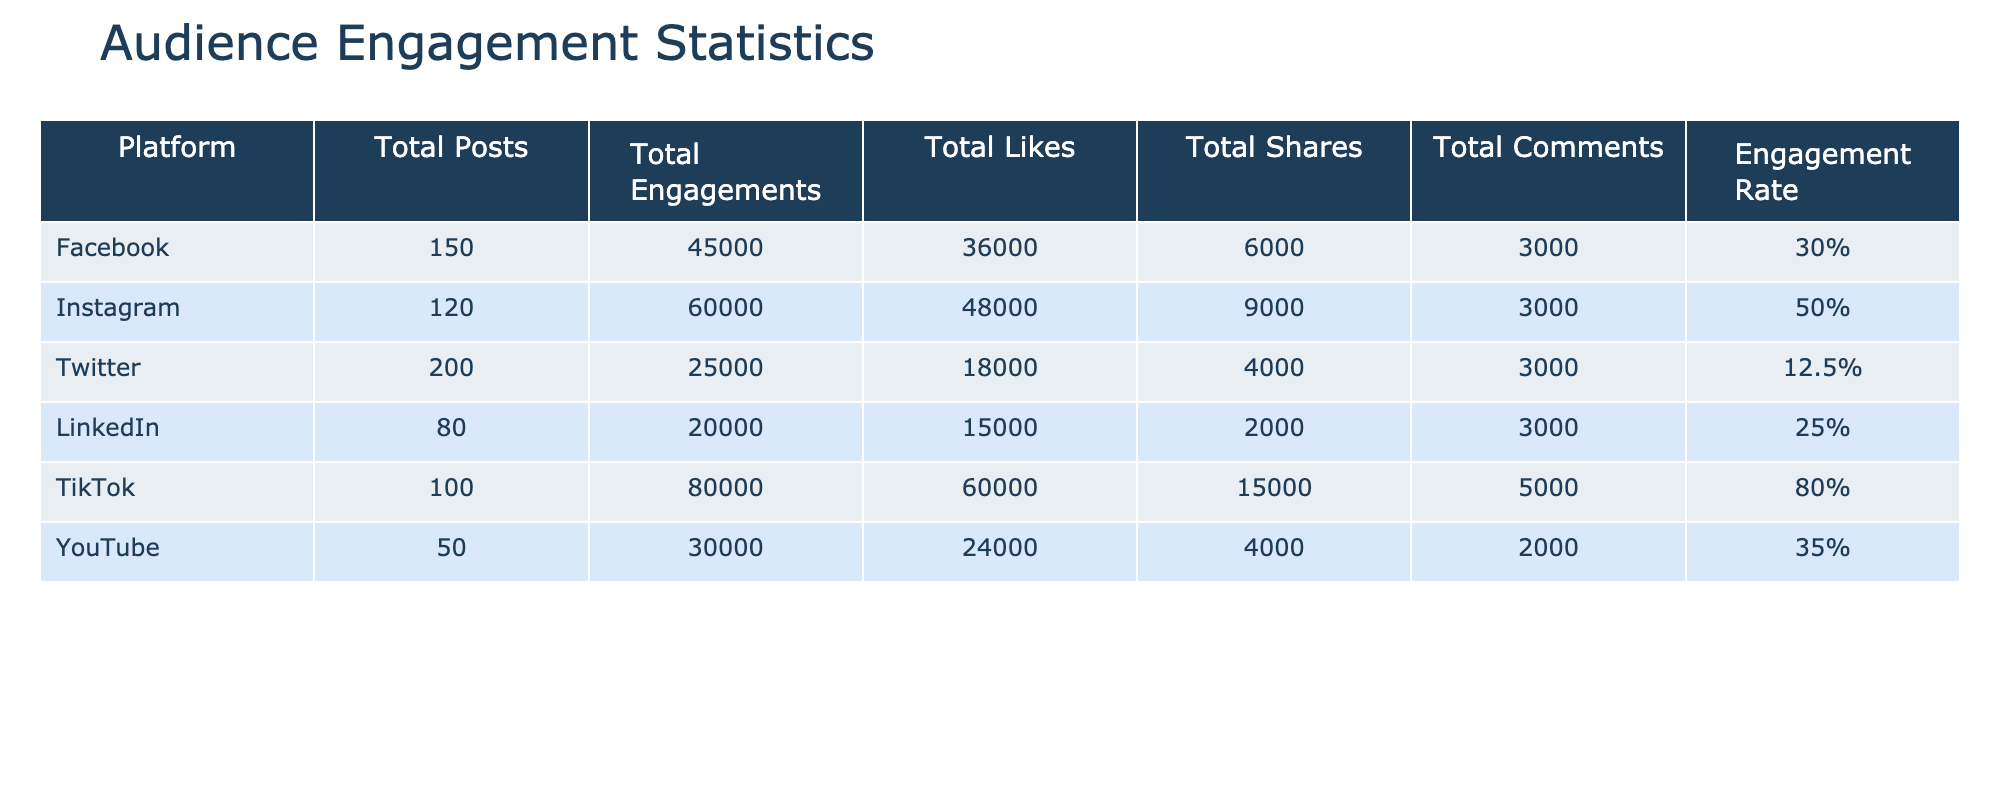What is the total number of engagements on Instagram? The table shows that the total number of engagements for Instagram is listed directly as 60000.
Answer: 60000 Which platform had the highest engagement rate and what was that rate? The table indicates that TikTok had the highest engagement rate at 80%.
Answer: 80% How many total likes did Facebook receive? According to the table, the total likes for Facebook are stated as 36000.
Answer: 36000 What platform had the least number of total posts and how many were there? By comparing the total posts across platforms, LinkedIn had the least with 80 posts.
Answer: 80 What is the sum of total shares from Facebook and YouTube? The table shows that Facebook had 6000 shares and YouTube had 4000 shares. Summing these gives 6000 + 4000 = 10000.
Answer: 10000 Is the total engagement on Twitter greater than that on LinkedIn? The table indicates that Twitter has 25000 total engagements and LinkedIn has 20000. Since 25000 is greater than 20000, the answer is yes.
Answer: Yes What is the average engagement rate across all platforms? To find the average engagement rate, sum the rates (30% + 50% + 12.5% + 25% + 80% + 35%) which equals 232.5%. There are 6 platforms, so we divide 232.5 by 6, leading to 38.75%.
Answer: 38.75% How many total comments did TikTok receive? The data shows that TikTok received a total of 5000 comments directly listed in the table.
Answer: 5000 Which platform had more total likes, YouTube or Twitter? According to the table, YouTube had 24000 likes while Twitter had 18000. Since 24000 is greater than 18000, the answer is YouTube.
Answer: YouTube 